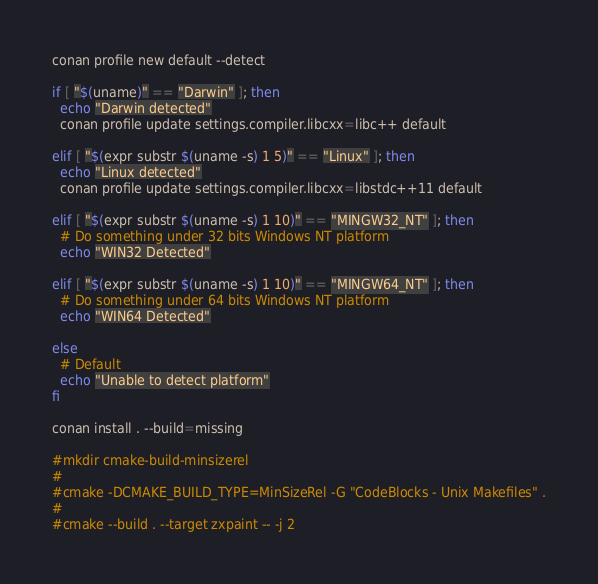<code> <loc_0><loc_0><loc_500><loc_500><_Bash_>conan profile new default --detect

if [ "$(uname)" == "Darwin" ]; then
  echo "Darwin detected"
  conan profile update settings.compiler.libcxx=libc++ default

elif [ "$(expr substr $(uname -s) 1 5)" == "Linux" ]; then
  echo "Linux detected"
  conan profile update settings.compiler.libcxx=libstdc++11 default

elif [ "$(expr substr $(uname -s) 1 10)" == "MINGW32_NT" ]; then
  # Do something under 32 bits Windows NT platform
  echo "WIN32 Detected"

elif [ "$(expr substr $(uname -s) 1 10)" == "MINGW64_NT" ]; then
  # Do something under 64 bits Windows NT platform
  echo "WIN64 Detected"

else
  # Default
  echo "Unable to detect platform"
fi

conan install . --build=missing

#mkdir cmake-build-minsizerel
#
#cmake -DCMAKE_BUILD_TYPE=MinSizeRel -G "CodeBlocks - Unix Makefiles" .
#
#cmake --build . --target zxpaint -- -j 2</code> 